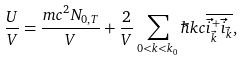<formula> <loc_0><loc_0><loc_500><loc_500>\frac { U } { V } = \frac { m c ^ { 2 } N _ { 0 , T } } { V } + \frac { 2 } { V } \sum _ { 0 < k < k _ { 0 } } \hbar { k } c \overline { \vec { i } ^ { + } _ { \vec { k } } \vec { i } _ { \vec { k } } } ,</formula> 